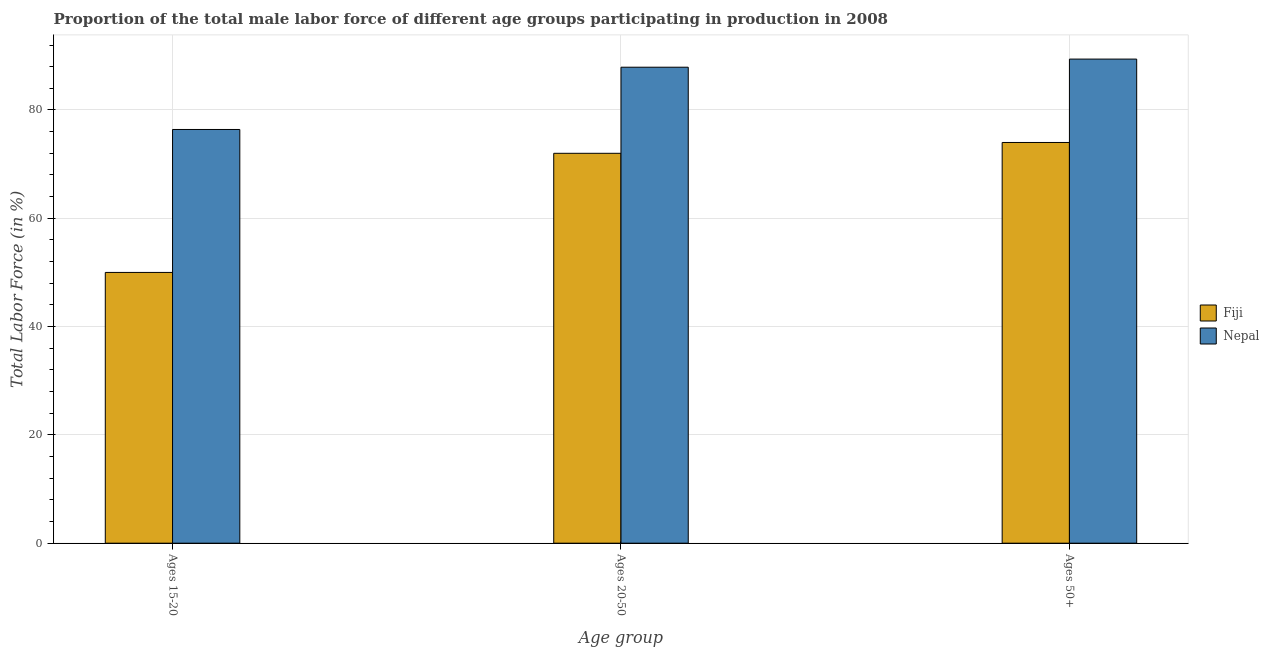Are the number of bars per tick equal to the number of legend labels?
Make the answer very short. Yes. Are the number of bars on each tick of the X-axis equal?
Provide a short and direct response. Yes. How many bars are there on the 2nd tick from the left?
Keep it short and to the point. 2. What is the label of the 3rd group of bars from the left?
Your response must be concise. Ages 50+. What is the percentage of male labor force above age 50 in Fiji?
Your answer should be very brief. 74. Across all countries, what is the maximum percentage of male labor force above age 50?
Offer a terse response. 89.4. In which country was the percentage of male labor force above age 50 maximum?
Offer a very short reply. Nepal. In which country was the percentage of male labor force above age 50 minimum?
Your response must be concise. Fiji. What is the total percentage of male labor force within the age group 15-20 in the graph?
Give a very brief answer. 126.4. What is the difference between the percentage of male labor force within the age group 15-20 in Fiji and that in Nepal?
Your answer should be compact. -26.4. What is the difference between the percentage of male labor force above age 50 in Nepal and the percentage of male labor force within the age group 20-50 in Fiji?
Give a very brief answer. 17.4. What is the average percentage of male labor force above age 50 per country?
Your response must be concise. 81.7. What is the ratio of the percentage of male labor force within the age group 20-50 in Fiji to that in Nepal?
Offer a terse response. 0.82. Is the difference between the percentage of male labor force above age 50 in Nepal and Fiji greater than the difference between the percentage of male labor force within the age group 15-20 in Nepal and Fiji?
Ensure brevity in your answer.  No. What is the difference between the highest and the second highest percentage of male labor force within the age group 20-50?
Ensure brevity in your answer.  15.9. What is the difference between the highest and the lowest percentage of male labor force above age 50?
Your answer should be compact. 15.4. Is the sum of the percentage of male labor force within the age group 20-50 in Nepal and Fiji greater than the maximum percentage of male labor force within the age group 15-20 across all countries?
Your answer should be very brief. Yes. What does the 2nd bar from the left in Ages 20-50 represents?
Ensure brevity in your answer.  Nepal. What does the 2nd bar from the right in Ages 20-50 represents?
Provide a succinct answer. Fiji. Is it the case that in every country, the sum of the percentage of male labor force within the age group 15-20 and percentage of male labor force within the age group 20-50 is greater than the percentage of male labor force above age 50?
Provide a succinct answer. Yes. Does the graph contain any zero values?
Offer a terse response. No. Does the graph contain grids?
Your response must be concise. Yes. Where does the legend appear in the graph?
Keep it short and to the point. Center right. How many legend labels are there?
Give a very brief answer. 2. What is the title of the graph?
Your response must be concise. Proportion of the total male labor force of different age groups participating in production in 2008. What is the label or title of the X-axis?
Offer a terse response. Age group. What is the Total Labor Force (in %) in Nepal in Ages 15-20?
Provide a short and direct response. 76.4. What is the Total Labor Force (in %) of Fiji in Ages 20-50?
Offer a terse response. 72. What is the Total Labor Force (in %) of Nepal in Ages 20-50?
Ensure brevity in your answer.  87.9. What is the Total Labor Force (in %) in Fiji in Ages 50+?
Provide a succinct answer. 74. What is the Total Labor Force (in %) of Nepal in Ages 50+?
Offer a very short reply. 89.4. Across all Age group, what is the maximum Total Labor Force (in %) in Nepal?
Your answer should be very brief. 89.4. Across all Age group, what is the minimum Total Labor Force (in %) of Nepal?
Offer a very short reply. 76.4. What is the total Total Labor Force (in %) of Fiji in the graph?
Provide a succinct answer. 196. What is the total Total Labor Force (in %) in Nepal in the graph?
Provide a short and direct response. 253.7. What is the difference between the Total Labor Force (in %) of Fiji in Ages 15-20 and that in Ages 20-50?
Ensure brevity in your answer.  -22. What is the difference between the Total Labor Force (in %) of Fiji in Ages 15-20 and that in Ages 50+?
Provide a succinct answer. -24. What is the difference between the Total Labor Force (in %) in Fiji in Ages 20-50 and that in Ages 50+?
Your answer should be compact. -2. What is the difference between the Total Labor Force (in %) in Nepal in Ages 20-50 and that in Ages 50+?
Offer a terse response. -1.5. What is the difference between the Total Labor Force (in %) in Fiji in Ages 15-20 and the Total Labor Force (in %) in Nepal in Ages 20-50?
Your response must be concise. -37.9. What is the difference between the Total Labor Force (in %) in Fiji in Ages 15-20 and the Total Labor Force (in %) in Nepal in Ages 50+?
Keep it short and to the point. -39.4. What is the difference between the Total Labor Force (in %) of Fiji in Ages 20-50 and the Total Labor Force (in %) of Nepal in Ages 50+?
Ensure brevity in your answer.  -17.4. What is the average Total Labor Force (in %) of Fiji per Age group?
Offer a very short reply. 65.33. What is the average Total Labor Force (in %) in Nepal per Age group?
Ensure brevity in your answer.  84.57. What is the difference between the Total Labor Force (in %) in Fiji and Total Labor Force (in %) in Nepal in Ages 15-20?
Offer a very short reply. -26.4. What is the difference between the Total Labor Force (in %) in Fiji and Total Labor Force (in %) in Nepal in Ages 20-50?
Your answer should be compact. -15.9. What is the difference between the Total Labor Force (in %) in Fiji and Total Labor Force (in %) in Nepal in Ages 50+?
Offer a very short reply. -15.4. What is the ratio of the Total Labor Force (in %) of Fiji in Ages 15-20 to that in Ages 20-50?
Provide a succinct answer. 0.69. What is the ratio of the Total Labor Force (in %) of Nepal in Ages 15-20 to that in Ages 20-50?
Keep it short and to the point. 0.87. What is the ratio of the Total Labor Force (in %) of Fiji in Ages 15-20 to that in Ages 50+?
Offer a terse response. 0.68. What is the ratio of the Total Labor Force (in %) in Nepal in Ages 15-20 to that in Ages 50+?
Your answer should be very brief. 0.85. What is the ratio of the Total Labor Force (in %) of Fiji in Ages 20-50 to that in Ages 50+?
Ensure brevity in your answer.  0.97. What is the ratio of the Total Labor Force (in %) of Nepal in Ages 20-50 to that in Ages 50+?
Make the answer very short. 0.98. What is the difference between the highest and the lowest Total Labor Force (in %) of Fiji?
Keep it short and to the point. 24. What is the difference between the highest and the lowest Total Labor Force (in %) in Nepal?
Your response must be concise. 13. 